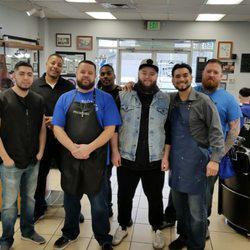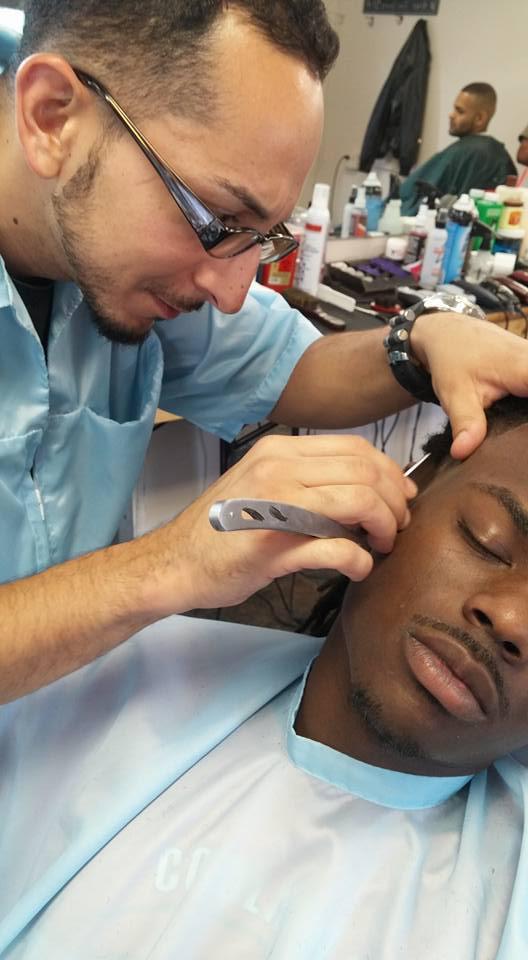The first image is the image on the left, the second image is the image on the right. Assess this claim about the two images: "Each image shows a barber in the foreground working on the hair of a customer wearing a smock, and only one of the images shows a customer in a blue smock.". Correct or not? Answer yes or no. No. The first image is the image on the left, the second image is the image on the right. Assess this claim about the two images: "The left and right image contains the same number of barbers shaving and combing men with dark hair.". Correct or not? Answer yes or no. No. 